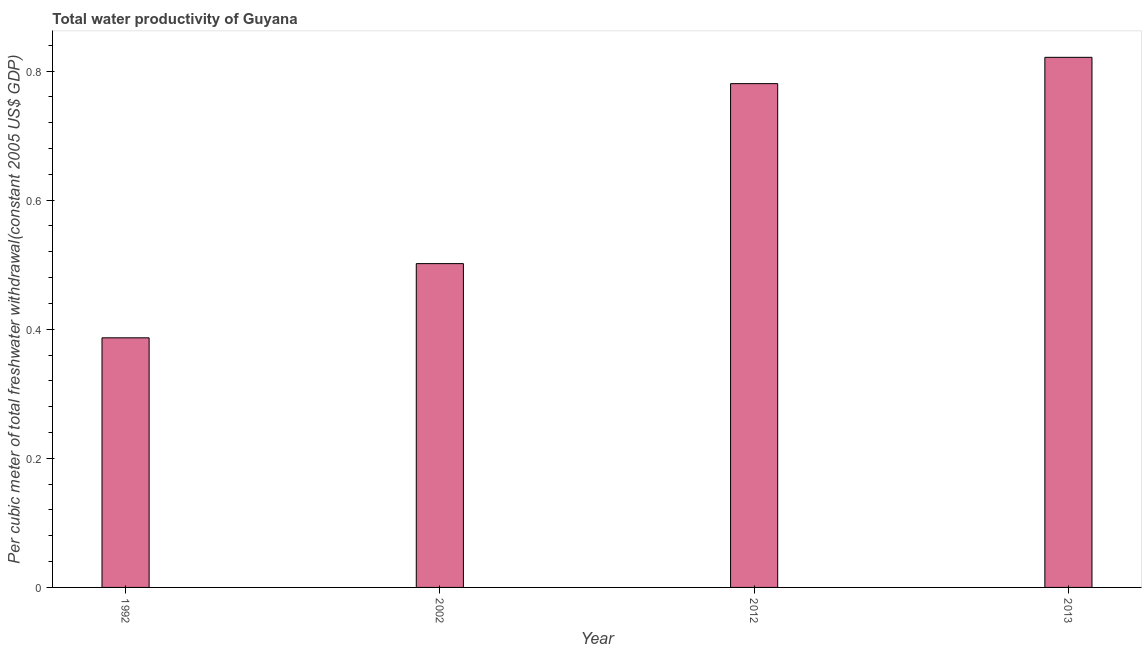What is the title of the graph?
Provide a succinct answer. Total water productivity of Guyana. What is the label or title of the Y-axis?
Ensure brevity in your answer.  Per cubic meter of total freshwater withdrawal(constant 2005 US$ GDP). What is the total water productivity in 2002?
Make the answer very short. 0.5. Across all years, what is the maximum total water productivity?
Your answer should be very brief. 0.82. Across all years, what is the minimum total water productivity?
Provide a succinct answer. 0.39. In which year was the total water productivity minimum?
Ensure brevity in your answer.  1992. What is the sum of the total water productivity?
Your answer should be very brief. 2.49. What is the difference between the total water productivity in 1992 and 2012?
Your response must be concise. -0.39. What is the average total water productivity per year?
Your response must be concise. 0.62. What is the median total water productivity?
Provide a short and direct response. 0.64. What is the ratio of the total water productivity in 1992 to that in 2012?
Make the answer very short. 0.49. Is the total water productivity in 1992 less than that in 2013?
Your response must be concise. Yes. Is the difference between the total water productivity in 1992 and 2012 greater than the difference between any two years?
Your answer should be compact. No. What is the difference between the highest and the second highest total water productivity?
Your response must be concise. 0.04. What is the difference between the highest and the lowest total water productivity?
Your response must be concise. 0.43. In how many years, is the total water productivity greater than the average total water productivity taken over all years?
Your response must be concise. 2. Are all the bars in the graph horizontal?
Give a very brief answer. No. What is the difference between two consecutive major ticks on the Y-axis?
Your response must be concise. 0.2. Are the values on the major ticks of Y-axis written in scientific E-notation?
Make the answer very short. No. What is the Per cubic meter of total freshwater withdrawal(constant 2005 US$ GDP) in 1992?
Give a very brief answer. 0.39. What is the Per cubic meter of total freshwater withdrawal(constant 2005 US$ GDP) in 2002?
Your answer should be very brief. 0.5. What is the Per cubic meter of total freshwater withdrawal(constant 2005 US$ GDP) of 2012?
Offer a terse response. 0.78. What is the Per cubic meter of total freshwater withdrawal(constant 2005 US$ GDP) in 2013?
Make the answer very short. 0.82. What is the difference between the Per cubic meter of total freshwater withdrawal(constant 2005 US$ GDP) in 1992 and 2002?
Your answer should be compact. -0.11. What is the difference between the Per cubic meter of total freshwater withdrawal(constant 2005 US$ GDP) in 1992 and 2012?
Provide a succinct answer. -0.39. What is the difference between the Per cubic meter of total freshwater withdrawal(constant 2005 US$ GDP) in 1992 and 2013?
Make the answer very short. -0.43. What is the difference between the Per cubic meter of total freshwater withdrawal(constant 2005 US$ GDP) in 2002 and 2012?
Provide a succinct answer. -0.28. What is the difference between the Per cubic meter of total freshwater withdrawal(constant 2005 US$ GDP) in 2002 and 2013?
Give a very brief answer. -0.32. What is the difference between the Per cubic meter of total freshwater withdrawal(constant 2005 US$ GDP) in 2012 and 2013?
Make the answer very short. -0.04. What is the ratio of the Per cubic meter of total freshwater withdrawal(constant 2005 US$ GDP) in 1992 to that in 2002?
Keep it short and to the point. 0.77. What is the ratio of the Per cubic meter of total freshwater withdrawal(constant 2005 US$ GDP) in 1992 to that in 2012?
Provide a short and direct response. 0.49. What is the ratio of the Per cubic meter of total freshwater withdrawal(constant 2005 US$ GDP) in 1992 to that in 2013?
Your answer should be compact. 0.47. What is the ratio of the Per cubic meter of total freshwater withdrawal(constant 2005 US$ GDP) in 2002 to that in 2012?
Your answer should be compact. 0.64. What is the ratio of the Per cubic meter of total freshwater withdrawal(constant 2005 US$ GDP) in 2002 to that in 2013?
Your response must be concise. 0.61. 